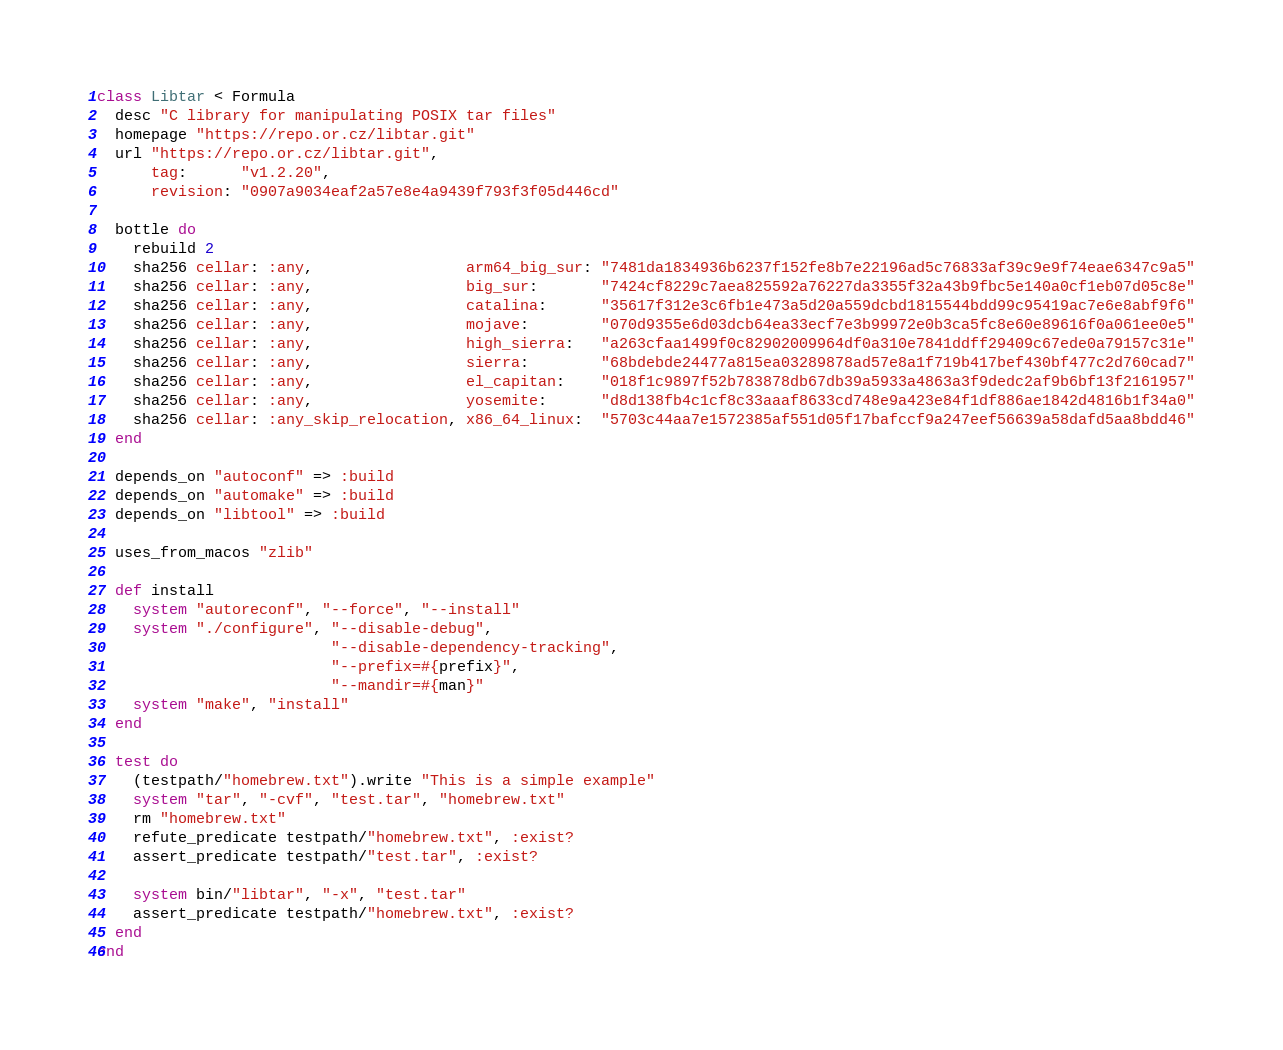<code> <loc_0><loc_0><loc_500><loc_500><_Ruby_>class Libtar < Formula
  desc "C library for manipulating POSIX tar files"
  homepage "https://repo.or.cz/libtar.git"
  url "https://repo.or.cz/libtar.git",
      tag:      "v1.2.20",
      revision: "0907a9034eaf2a57e8e4a9439f793f3f05d446cd"

  bottle do
    rebuild 2
    sha256 cellar: :any,                 arm64_big_sur: "7481da1834936b6237f152fe8b7e22196ad5c76833af39c9e9f74eae6347c9a5"
    sha256 cellar: :any,                 big_sur:       "7424cf8229c7aea825592a76227da3355f32a43b9fbc5e140a0cf1eb07d05c8e"
    sha256 cellar: :any,                 catalina:      "35617f312e3c6fb1e473a5d20a559dcbd1815544bdd99c95419ac7e6e8abf9f6"
    sha256 cellar: :any,                 mojave:        "070d9355e6d03dcb64ea33ecf7e3b99972e0b3ca5fc8e60e89616f0a061ee0e5"
    sha256 cellar: :any,                 high_sierra:   "a263cfaa1499f0c82902009964df0a310e7841ddff29409c67ede0a79157c31e"
    sha256 cellar: :any,                 sierra:        "68bdebde24477a815ea03289878ad57e8a1f719b417bef430bf477c2d760cad7"
    sha256 cellar: :any,                 el_capitan:    "018f1c9897f52b783878db67db39a5933a4863a3f9dedc2af9b6bf13f2161957"
    sha256 cellar: :any,                 yosemite:      "d8d138fb4c1cf8c33aaaf8633cd748e9a423e84f1df886ae1842d4816b1f34a0"
    sha256 cellar: :any_skip_relocation, x86_64_linux:  "5703c44aa7e1572385af551d05f17bafccf9a247eef56639a58dafd5aa8bdd46"
  end

  depends_on "autoconf" => :build
  depends_on "automake" => :build
  depends_on "libtool" => :build

  uses_from_macos "zlib"

  def install
    system "autoreconf", "--force", "--install"
    system "./configure", "--disable-debug",
                          "--disable-dependency-tracking",
                          "--prefix=#{prefix}",
                          "--mandir=#{man}"
    system "make", "install"
  end

  test do
    (testpath/"homebrew.txt").write "This is a simple example"
    system "tar", "-cvf", "test.tar", "homebrew.txt"
    rm "homebrew.txt"
    refute_predicate testpath/"homebrew.txt", :exist?
    assert_predicate testpath/"test.tar", :exist?

    system bin/"libtar", "-x", "test.tar"
    assert_predicate testpath/"homebrew.txt", :exist?
  end
end
</code> 